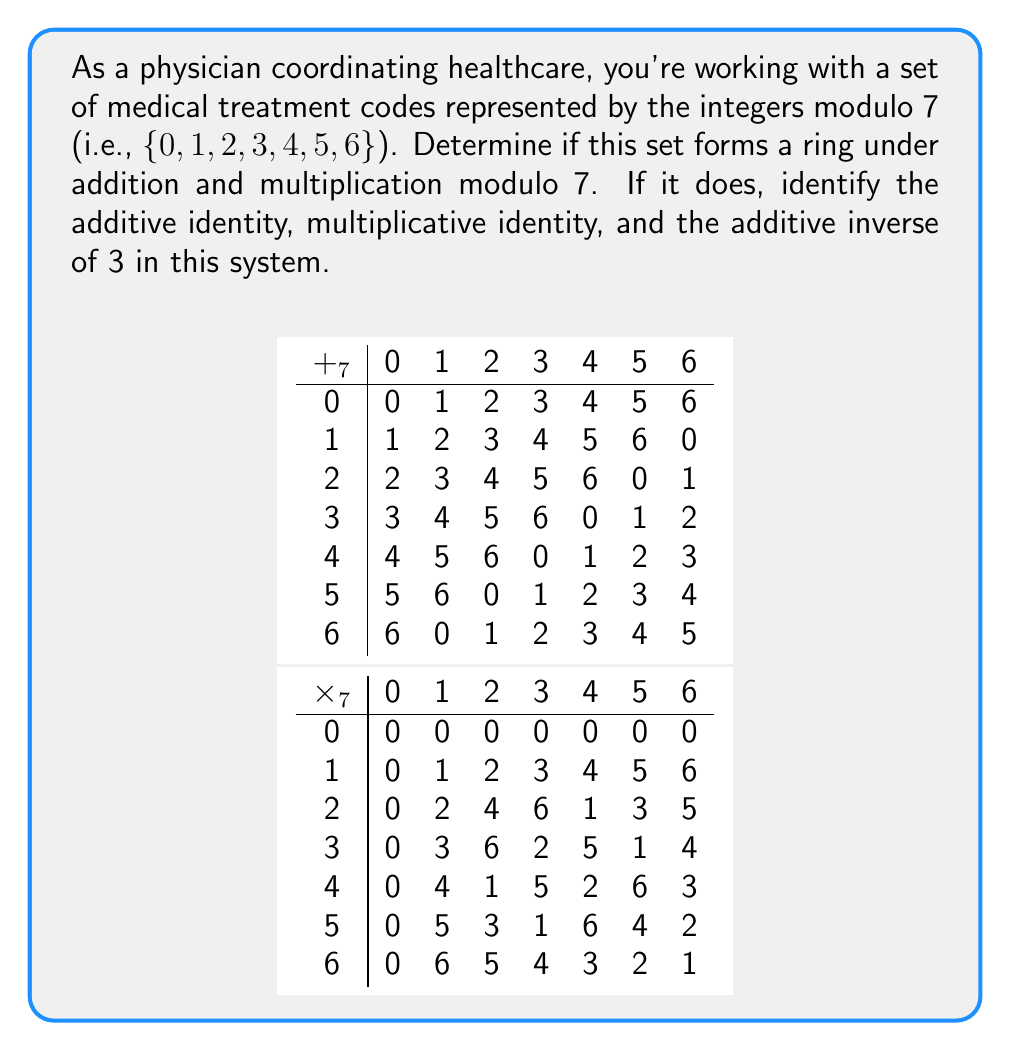Provide a solution to this math problem. To determine if the set of medical treatment codes forms a ring, we need to check if it satisfies the ring axioms:

1. Closure under addition and multiplication:
   For any $a, b \in \{0, 1, 2, 3, 4, 5, 6\}$, $a + b \pmod{7}$ and $a \cdot b \pmod{7}$ are also in the set.

2. Associativity of addition and multiplication:
   $(a + b) + c = a + (b + c)$ and $(a \cdot b) \cdot c = a \cdot (b \cdot c)$ for all $a, b, c$ in the set.

3. Commutativity of addition:
   $a + b = b + a$ for all $a, b$ in the set.

4. Additive identity:
   There exists an element 0 such that $a + 0 = a$ for all $a$ in the set.

5. Additive inverses:
   For each $a$ in the set, there exists $-a$ such that $a + (-a) = 0$.

6. Distributivity:
   $a \cdot (b + c) = (a \cdot b) + (a \cdot c)$ for all $a, b, c$ in the set.

The integers modulo 7 satisfy all these properties:

1. Closure: Addition and multiplication modulo 7 always result in an element of the set.
2. Associativity: Both operations are associative.
3. Commutativity of addition: Addition is commutative.
4. Additive identity: 0 is the additive identity.
5. Additive inverses: Each element has an additive inverse (e.g., 3 and 4 are additive inverses since $3 + 4 \equiv 0 \pmod{7}$).
6. Distributivity: The distributive property holds.

Therefore, this set forms a ring under addition and multiplication modulo 7.

The additive identity is 0.
The multiplicative identity is 1.
The additive inverse of 3 is 4 because $3 + 4 \equiv 0 \pmod{7}$.
Answer: Yes; additive identity: 0; multiplicative identity: 1; additive inverse of 3: 4 